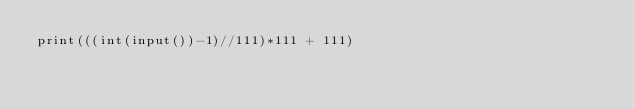<code> <loc_0><loc_0><loc_500><loc_500><_Python_>print(((int(input())-1)//111)*111 + 111)</code> 